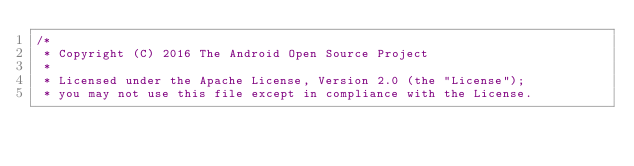<code> <loc_0><loc_0><loc_500><loc_500><_Java_>/*
 * Copyright (C) 2016 The Android Open Source Project
 *
 * Licensed under the Apache License, Version 2.0 (the "License");
 * you may not use this file except in compliance with the License.</code> 